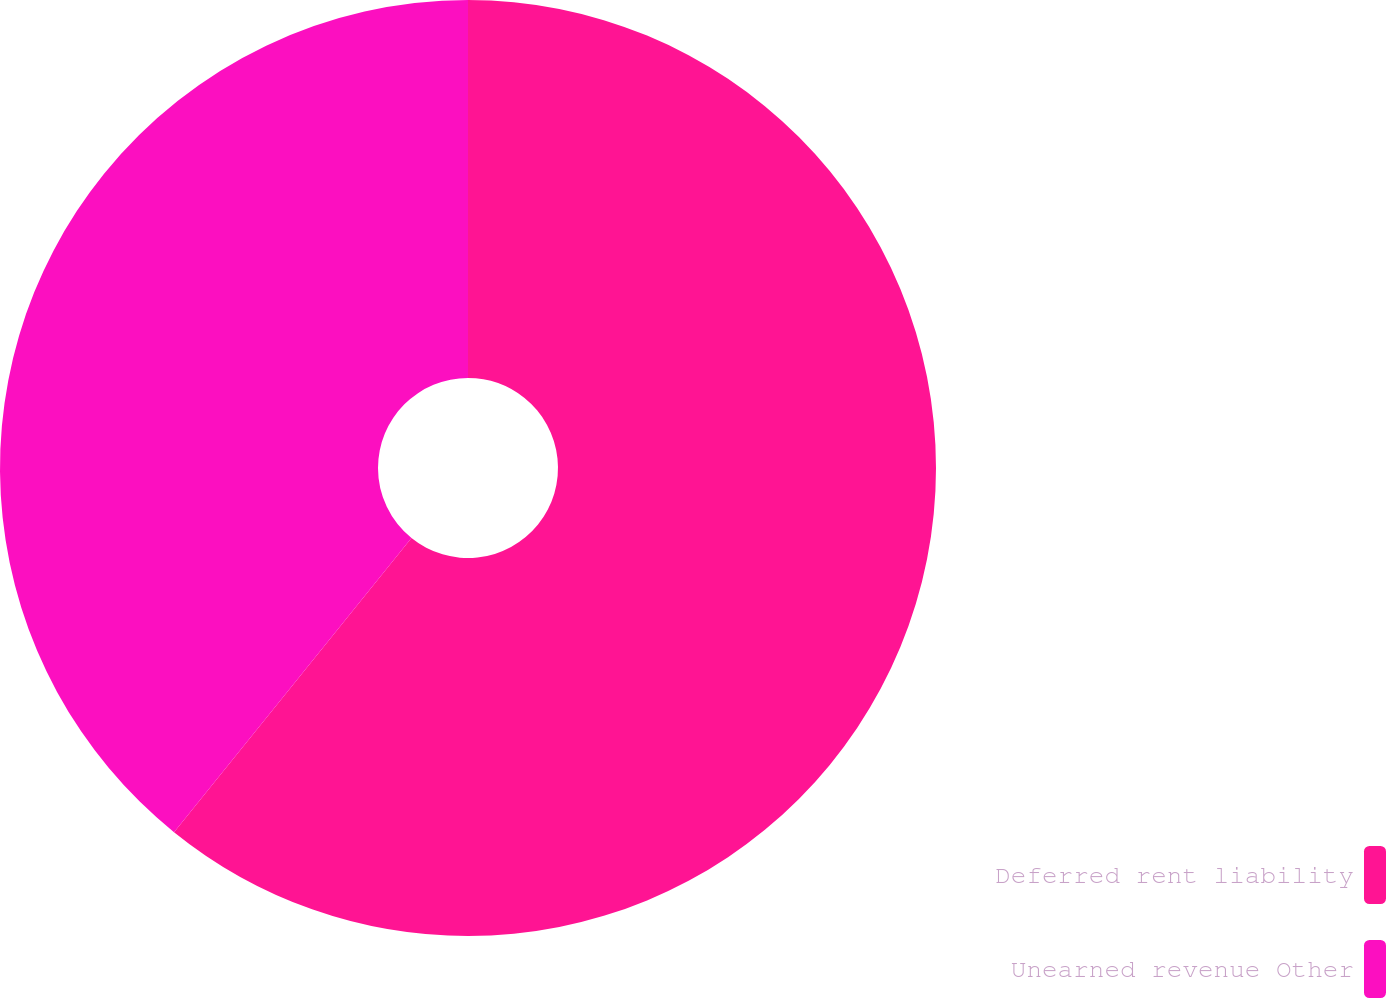<chart> <loc_0><loc_0><loc_500><loc_500><pie_chart><fcel>Deferred rent liability<fcel>Unearned revenue Other<nl><fcel>60.81%<fcel>39.19%<nl></chart> 